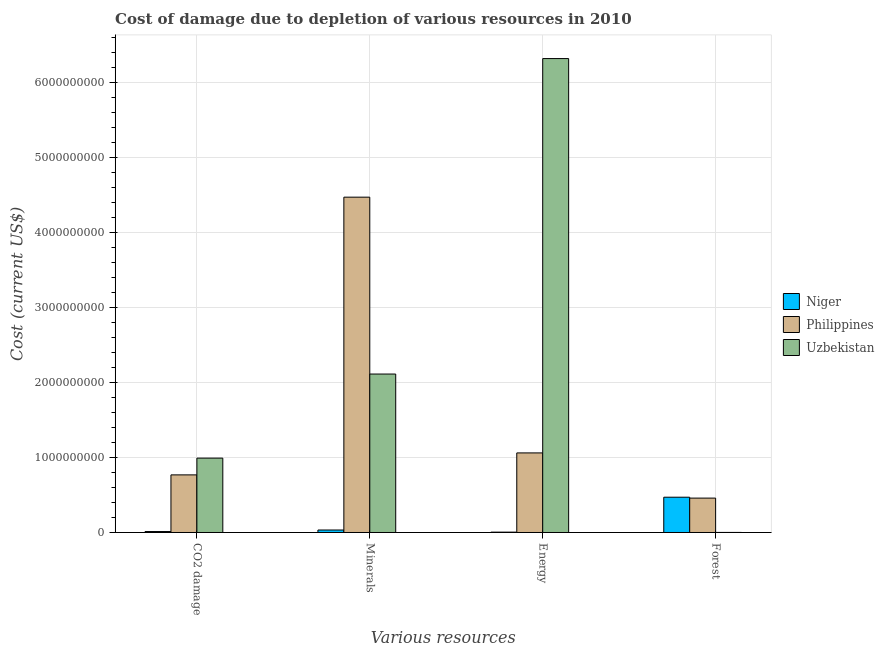How many groups of bars are there?
Provide a short and direct response. 4. Are the number of bars per tick equal to the number of legend labels?
Your answer should be very brief. Yes. Are the number of bars on each tick of the X-axis equal?
Keep it short and to the point. Yes. What is the label of the 4th group of bars from the left?
Ensure brevity in your answer.  Forest. What is the cost of damage due to depletion of coal in Philippines?
Make the answer very short. 7.68e+08. Across all countries, what is the maximum cost of damage due to depletion of minerals?
Ensure brevity in your answer.  4.47e+09. Across all countries, what is the minimum cost of damage due to depletion of minerals?
Your answer should be compact. 3.30e+07. In which country was the cost of damage due to depletion of coal maximum?
Ensure brevity in your answer.  Uzbekistan. In which country was the cost of damage due to depletion of minerals minimum?
Your answer should be very brief. Niger. What is the total cost of damage due to depletion of minerals in the graph?
Offer a terse response. 6.62e+09. What is the difference between the cost of damage due to depletion of minerals in Niger and that in Uzbekistan?
Ensure brevity in your answer.  -2.08e+09. What is the difference between the cost of damage due to depletion of forests in Uzbekistan and the cost of damage due to depletion of minerals in Philippines?
Your response must be concise. -4.47e+09. What is the average cost of damage due to depletion of forests per country?
Provide a succinct answer. 3.10e+08. What is the difference between the cost of damage due to depletion of forests and cost of damage due to depletion of minerals in Uzbekistan?
Keep it short and to the point. -2.11e+09. In how many countries, is the cost of damage due to depletion of minerals greater than 2800000000 US$?
Provide a short and direct response. 1. What is the ratio of the cost of damage due to depletion of energy in Niger to that in Philippines?
Give a very brief answer. 0. Is the cost of damage due to depletion of forests in Niger less than that in Philippines?
Your answer should be compact. No. What is the difference between the highest and the second highest cost of damage due to depletion of energy?
Provide a short and direct response. 5.26e+09. What is the difference between the highest and the lowest cost of damage due to depletion of energy?
Offer a terse response. 6.31e+09. Is it the case that in every country, the sum of the cost of damage due to depletion of coal and cost of damage due to depletion of minerals is greater than the sum of cost of damage due to depletion of energy and cost of damage due to depletion of forests?
Provide a succinct answer. No. Is it the case that in every country, the sum of the cost of damage due to depletion of coal and cost of damage due to depletion of minerals is greater than the cost of damage due to depletion of energy?
Offer a terse response. No. How many bars are there?
Give a very brief answer. 12. How many countries are there in the graph?
Provide a succinct answer. 3. What is the difference between two consecutive major ticks on the Y-axis?
Offer a very short reply. 1.00e+09. Does the graph contain any zero values?
Make the answer very short. No. Does the graph contain grids?
Make the answer very short. Yes. Where does the legend appear in the graph?
Offer a terse response. Center right. What is the title of the graph?
Ensure brevity in your answer.  Cost of damage due to depletion of various resources in 2010 . Does "Moldova" appear as one of the legend labels in the graph?
Offer a very short reply. No. What is the label or title of the X-axis?
Ensure brevity in your answer.  Various resources. What is the label or title of the Y-axis?
Offer a terse response. Cost (current US$). What is the Cost (current US$) in Niger in CO2 damage?
Make the answer very short. 1.27e+07. What is the Cost (current US$) in Philippines in CO2 damage?
Your answer should be very brief. 7.68e+08. What is the Cost (current US$) of Uzbekistan in CO2 damage?
Make the answer very short. 9.91e+08. What is the Cost (current US$) in Niger in Minerals?
Keep it short and to the point. 3.30e+07. What is the Cost (current US$) of Philippines in Minerals?
Your answer should be very brief. 4.47e+09. What is the Cost (current US$) of Uzbekistan in Minerals?
Ensure brevity in your answer.  2.11e+09. What is the Cost (current US$) in Niger in Energy?
Offer a very short reply. 4.68e+06. What is the Cost (current US$) in Philippines in Energy?
Your answer should be very brief. 1.06e+09. What is the Cost (current US$) in Uzbekistan in Energy?
Provide a succinct answer. 6.32e+09. What is the Cost (current US$) in Niger in Forest?
Offer a very short reply. 4.70e+08. What is the Cost (current US$) of Philippines in Forest?
Your answer should be compact. 4.58e+08. What is the Cost (current US$) of Uzbekistan in Forest?
Your answer should be very brief. 7.61e+05. Across all Various resources, what is the maximum Cost (current US$) in Niger?
Offer a very short reply. 4.70e+08. Across all Various resources, what is the maximum Cost (current US$) in Philippines?
Your response must be concise. 4.47e+09. Across all Various resources, what is the maximum Cost (current US$) of Uzbekistan?
Provide a succinct answer. 6.32e+09. Across all Various resources, what is the minimum Cost (current US$) of Niger?
Your response must be concise. 4.68e+06. Across all Various resources, what is the minimum Cost (current US$) in Philippines?
Your answer should be compact. 4.58e+08. Across all Various resources, what is the minimum Cost (current US$) in Uzbekistan?
Keep it short and to the point. 7.61e+05. What is the total Cost (current US$) in Niger in the graph?
Ensure brevity in your answer.  5.21e+08. What is the total Cost (current US$) in Philippines in the graph?
Offer a terse response. 6.76e+09. What is the total Cost (current US$) of Uzbekistan in the graph?
Ensure brevity in your answer.  9.42e+09. What is the difference between the Cost (current US$) in Niger in CO2 damage and that in Minerals?
Provide a succinct answer. -2.03e+07. What is the difference between the Cost (current US$) of Philippines in CO2 damage and that in Minerals?
Provide a short and direct response. -3.70e+09. What is the difference between the Cost (current US$) in Uzbekistan in CO2 damage and that in Minerals?
Provide a succinct answer. -1.12e+09. What is the difference between the Cost (current US$) in Niger in CO2 damage and that in Energy?
Offer a very short reply. 8.04e+06. What is the difference between the Cost (current US$) of Philippines in CO2 damage and that in Energy?
Make the answer very short. -2.93e+08. What is the difference between the Cost (current US$) in Uzbekistan in CO2 damage and that in Energy?
Make the answer very short. -5.33e+09. What is the difference between the Cost (current US$) in Niger in CO2 damage and that in Forest?
Keep it short and to the point. -4.58e+08. What is the difference between the Cost (current US$) of Philippines in CO2 damage and that in Forest?
Keep it short and to the point. 3.09e+08. What is the difference between the Cost (current US$) in Uzbekistan in CO2 damage and that in Forest?
Make the answer very short. 9.91e+08. What is the difference between the Cost (current US$) in Niger in Minerals and that in Energy?
Your answer should be very brief. 2.83e+07. What is the difference between the Cost (current US$) of Philippines in Minerals and that in Energy?
Make the answer very short. 3.41e+09. What is the difference between the Cost (current US$) in Uzbekistan in Minerals and that in Energy?
Offer a very short reply. -4.21e+09. What is the difference between the Cost (current US$) of Niger in Minerals and that in Forest?
Make the answer very short. -4.37e+08. What is the difference between the Cost (current US$) in Philippines in Minerals and that in Forest?
Your response must be concise. 4.01e+09. What is the difference between the Cost (current US$) in Uzbekistan in Minerals and that in Forest?
Your answer should be very brief. 2.11e+09. What is the difference between the Cost (current US$) of Niger in Energy and that in Forest?
Your answer should be very brief. -4.66e+08. What is the difference between the Cost (current US$) of Philippines in Energy and that in Forest?
Make the answer very short. 6.02e+08. What is the difference between the Cost (current US$) of Uzbekistan in Energy and that in Forest?
Your response must be concise. 6.32e+09. What is the difference between the Cost (current US$) of Niger in CO2 damage and the Cost (current US$) of Philippines in Minerals?
Give a very brief answer. -4.46e+09. What is the difference between the Cost (current US$) of Niger in CO2 damage and the Cost (current US$) of Uzbekistan in Minerals?
Provide a short and direct response. -2.10e+09. What is the difference between the Cost (current US$) in Philippines in CO2 damage and the Cost (current US$) in Uzbekistan in Minerals?
Offer a terse response. -1.34e+09. What is the difference between the Cost (current US$) of Niger in CO2 damage and the Cost (current US$) of Philippines in Energy?
Ensure brevity in your answer.  -1.05e+09. What is the difference between the Cost (current US$) in Niger in CO2 damage and the Cost (current US$) in Uzbekistan in Energy?
Your response must be concise. -6.31e+09. What is the difference between the Cost (current US$) in Philippines in CO2 damage and the Cost (current US$) in Uzbekistan in Energy?
Provide a succinct answer. -5.55e+09. What is the difference between the Cost (current US$) in Niger in CO2 damage and the Cost (current US$) in Philippines in Forest?
Provide a short and direct response. -4.46e+08. What is the difference between the Cost (current US$) of Niger in CO2 damage and the Cost (current US$) of Uzbekistan in Forest?
Your response must be concise. 1.20e+07. What is the difference between the Cost (current US$) in Philippines in CO2 damage and the Cost (current US$) in Uzbekistan in Forest?
Your answer should be very brief. 7.67e+08. What is the difference between the Cost (current US$) of Niger in Minerals and the Cost (current US$) of Philippines in Energy?
Your answer should be compact. -1.03e+09. What is the difference between the Cost (current US$) of Niger in Minerals and the Cost (current US$) of Uzbekistan in Energy?
Keep it short and to the point. -6.28e+09. What is the difference between the Cost (current US$) in Philippines in Minerals and the Cost (current US$) in Uzbekistan in Energy?
Your answer should be very brief. -1.85e+09. What is the difference between the Cost (current US$) in Niger in Minerals and the Cost (current US$) in Philippines in Forest?
Your response must be concise. -4.26e+08. What is the difference between the Cost (current US$) in Niger in Minerals and the Cost (current US$) in Uzbekistan in Forest?
Provide a succinct answer. 3.22e+07. What is the difference between the Cost (current US$) in Philippines in Minerals and the Cost (current US$) in Uzbekistan in Forest?
Your answer should be very brief. 4.47e+09. What is the difference between the Cost (current US$) in Niger in Energy and the Cost (current US$) in Philippines in Forest?
Your response must be concise. -4.54e+08. What is the difference between the Cost (current US$) in Niger in Energy and the Cost (current US$) in Uzbekistan in Forest?
Provide a short and direct response. 3.92e+06. What is the difference between the Cost (current US$) of Philippines in Energy and the Cost (current US$) of Uzbekistan in Forest?
Your answer should be compact. 1.06e+09. What is the average Cost (current US$) of Niger per Various resources?
Your answer should be very brief. 1.30e+08. What is the average Cost (current US$) in Philippines per Various resources?
Your answer should be compact. 1.69e+09. What is the average Cost (current US$) of Uzbekistan per Various resources?
Provide a succinct answer. 2.36e+09. What is the difference between the Cost (current US$) in Niger and Cost (current US$) in Philippines in CO2 damage?
Provide a short and direct response. -7.55e+08. What is the difference between the Cost (current US$) in Niger and Cost (current US$) in Uzbekistan in CO2 damage?
Keep it short and to the point. -9.79e+08. What is the difference between the Cost (current US$) in Philippines and Cost (current US$) in Uzbekistan in CO2 damage?
Your answer should be very brief. -2.24e+08. What is the difference between the Cost (current US$) of Niger and Cost (current US$) of Philippines in Minerals?
Provide a short and direct response. -4.44e+09. What is the difference between the Cost (current US$) of Niger and Cost (current US$) of Uzbekistan in Minerals?
Provide a short and direct response. -2.08e+09. What is the difference between the Cost (current US$) in Philippines and Cost (current US$) in Uzbekistan in Minerals?
Offer a terse response. 2.36e+09. What is the difference between the Cost (current US$) in Niger and Cost (current US$) in Philippines in Energy?
Your response must be concise. -1.06e+09. What is the difference between the Cost (current US$) of Niger and Cost (current US$) of Uzbekistan in Energy?
Offer a very short reply. -6.31e+09. What is the difference between the Cost (current US$) in Philippines and Cost (current US$) in Uzbekistan in Energy?
Your answer should be very brief. -5.26e+09. What is the difference between the Cost (current US$) in Niger and Cost (current US$) in Philippines in Forest?
Your answer should be compact. 1.18e+07. What is the difference between the Cost (current US$) in Niger and Cost (current US$) in Uzbekistan in Forest?
Your answer should be compact. 4.69e+08. What is the difference between the Cost (current US$) in Philippines and Cost (current US$) in Uzbekistan in Forest?
Your answer should be compact. 4.58e+08. What is the ratio of the Cost (current US$) of Niger in CO2 damage to that in Minerals?
Make the answer very short. 0.39. What is the ratio of the Cost (current US$) in Philippines in CO2 damage to that in Minerals?
Your answer should be very brief. 0.17. What is the ratio of the Cost (current US$) in Uzbekistan in CO2 damage to that in Minerals?
Keep it short and to the point. 0.47. What is the ratio of the Cost (current US$) of Niger in CO2 damage to that in Energy?
Offer a terse response. 2.72. What is the ratio of the Cost (current US$) in Philippines in CO2 damage to that in Energy?
Provide a short and direct response. 0.72. What is the ratio of the Cost (current US$) of Uzbekistan in CO2 damage to that in Energy?
Make the answer very short. 0.16. What is the ratio of the Cost (current US$) in Niger in CO2 damage to that in Forest?
Provide a short and direct response. 0.03. What is the ratio of the Cost (current US$) of Philippines in CO2 damage to that in Forest?
Give a very brief answer. 1.67. What is the ratio of the Cost (current US$) of Uzbekistan in CO2 damage to that in Forest?
Your response must be concise. 1302.57. What is the ratio of the Cost (current US$) of Niger in Minerals to that in Energy?
Provide a short and direct response. 7.05. What is the ratio of the Cost (current US$) in Philippines in Minerals to that in Energy?
Your answer should be compact. 4.21. What is the ratio of the Cost (current US$) of Uzbekistan in Minerals to that in Energy?
Provide a succinct answer. 0.33. What is the ratio of the Cost (current US$) of Niger in Minerals to that in Forest?
Give a very brief answer. 0.07. What is the ratio of the Cost (current US$) of Philippines in Minerals to that in Forest?
Your answer should be compact. 9.75. What is the ratio of the Cost (current US$) in Uzbekistan in Minerals to that in Forest?
Provide a short and direct response. 2775.36. What is the ratio of the Cost (current US$) of Niger in Energy to that in Forest?
Provide a succinct answer. 0.01. What is the ratio of the Cost (current US$) of Philippines in Energy to that in Forest?
Offer a very short reply. 2.31. What is the ratio of the Cost (current US$) of Uzbekistan in Energy to that in Forest?
Your response must be concise. 8300.91. What is the difference between the highest and the second highest Cost (current US$) in Niger?
Provide a succinct answer. 4.37e+08. What is the difference between the highest and the second highest Cost (current US$) of Philippines?
Give a very brief answer. 3.41e+09. What is the difference between the highest and the second highest Cost (current US$) in Uzbekistan?
Provide a short and direct response. 4.21e+09. What is the difference between the highest and the lowest Cost (current US$) in Niger?
Offer a very short reply. 4.66e+08. What is the difference between the highest and the lowest Cost (current US$) of Philippines?
Provide a succinct answer. 4.01e+09. What is the difference between the highest and the lowest Cost (current US$) of Uzbekistan?
Keep it short and to the point. 6.32e+09. 